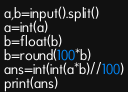Convert code to text. <code><loc_0><loc_0><loc_500><loc_500><_Python_>a,b=input().split()
a=int(a)
b=float(b)
b=round(100*b)
ans=int(int(a*b)//100)
print(ans)</code> 